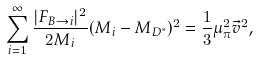<formula> <loc_0><loc_0><loc_500><loc_500>\sum _ { i = 1 } ^ { \infty } \frac { | F _ { B \rightarrow i } | ^ { 2 } } { 2 M _ { i } } ( M _ { i } - M _ { D ^ { * } } ) ^ { 2 } = \frac { 1 } { 3 } \mu _ { \pi } ^ { 2 } { \vec { v } } ^ { 2 } ,</formula> 